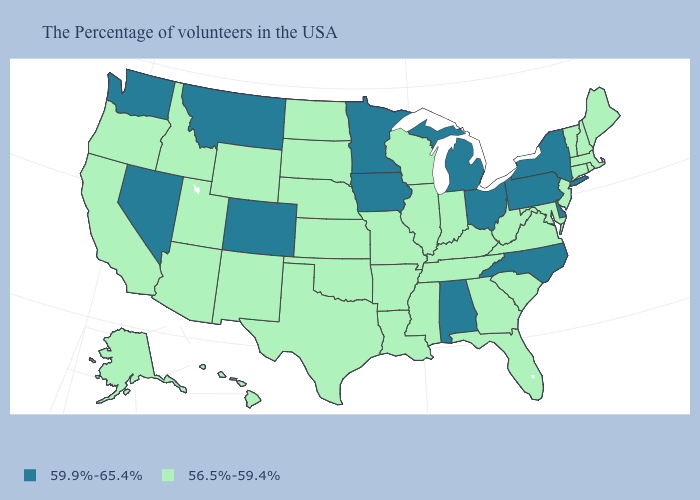Which states have the highest value in the USA?
Answer briefly. New York, Delaware, Pennsylvania, North Carolina, Ohio, Michigan, Alabama, Minnesota, Iowa, Colorado, Montana, Nevada, Washington. What is the value of Alaska?
Short answer required. 56.5%-59.4%. What is the highest value in the MidWest ?
Quick response, please. 59.9%-65.4%. What is the lowest value in states that border New Jersey?
Be succinct. 59.9%-65.4%. Does the map have missing data?
Write a very short answer. No. What is the value of Iowa?
Give a very brief answer. 59.9%-65.4%. Name the states that have a value in the range 56.5%-59.4%?
Write a very short answer. Maine, Massachusetts, Rhode Island, New Hampshire, Vermont, Connecticut, New Jersey, Maryland, Virginia, South Carolina, West Virginia, Florida, Georgia, Kentucky, Indiana, Tennessee, Wisconsin, Illinois, Mississippi, Louisiana, Missouri, Arkansas, Kansas, Nebraska, Oklahoma, Texas, South Dakota, North Dakota, Wyoming, New Mexico, Utah, Arizona, Idaho, California, Oregon, Alaska, Hawaii. Which states have the highest value in the USA?
Quick response, please. New York, Delaware, Pennsylvania, North Carolina, Ohio, Michigan, Alabama, Minnesota, Iowa, Colorado, Montana, Nevada, Washington. What is the lowest value in states that border Florida?
Write a very short answer. 56.5%-59.4%. What is the highest value in the USA?
Write a very short answer. 59.9%-65.4%. What is the value of Missouri?
Give a very brief answer. 56.5%-59.4%. Among the states that border New Mexico , does Colorado have the lowest value?
Short answer required. No. Name the states that have a value in the range 56.5%-59.4%?
Write a very short answer. Maine, Massachusetts, Rhode Island, New Hampshire, Vermont, Connecticut, New Jersey, Maryland, Virginia, South Carolina, West Virginia, Florida, Georgia, Kentucky, Indiana, Tennessee, Wisconsin, Illinois, Mississippi, Louisiana, Missouri, Arkansas, Kansas, Nebraska, Oklahoma, Texas, South Dakota, North Dakota, Wyoming, New Mexico, Utah, Arizona, Idaho, California, Oregon, Alaska, Hawaii. Among the states that border South Carolina , which have the highest value?
Answer briefly. North Carolina. What is the lowest value in the USA?
Write a very short answer. 56.5%-59.4%. 